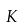<formula> <loc_0><loc_0><loc_500><loc_500>K</formula> 